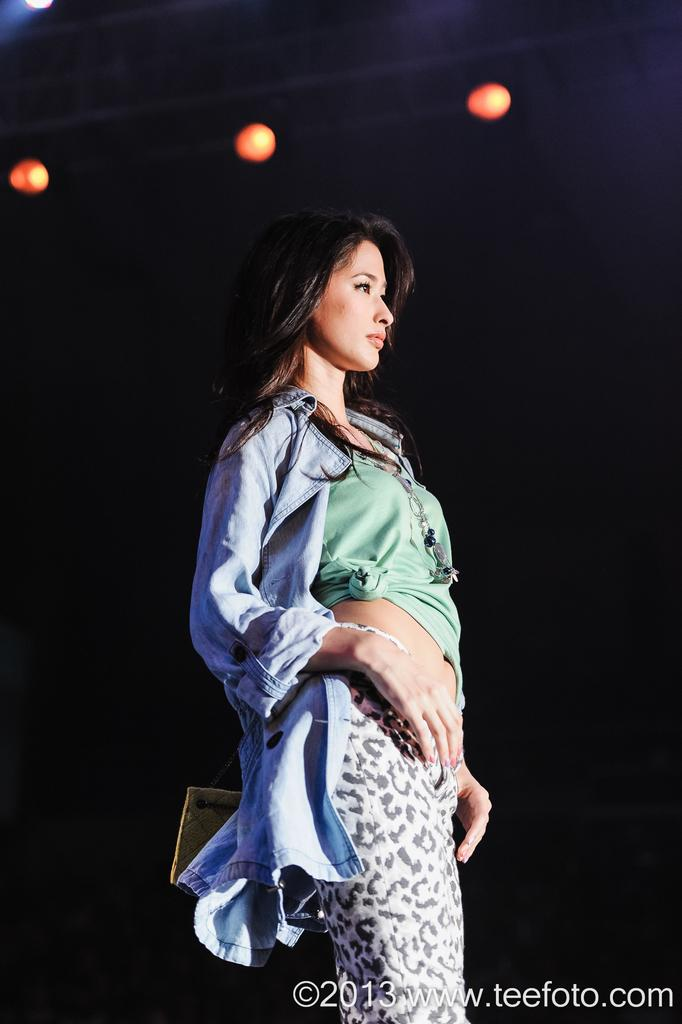Who is the main subject in the image? There is a lady in the center of the image. What can be seen at the top of the image? There are lights present at the top of the image. What type of card is the lady holding in the image? There is no card present in the image; the lady is not holding anything. 